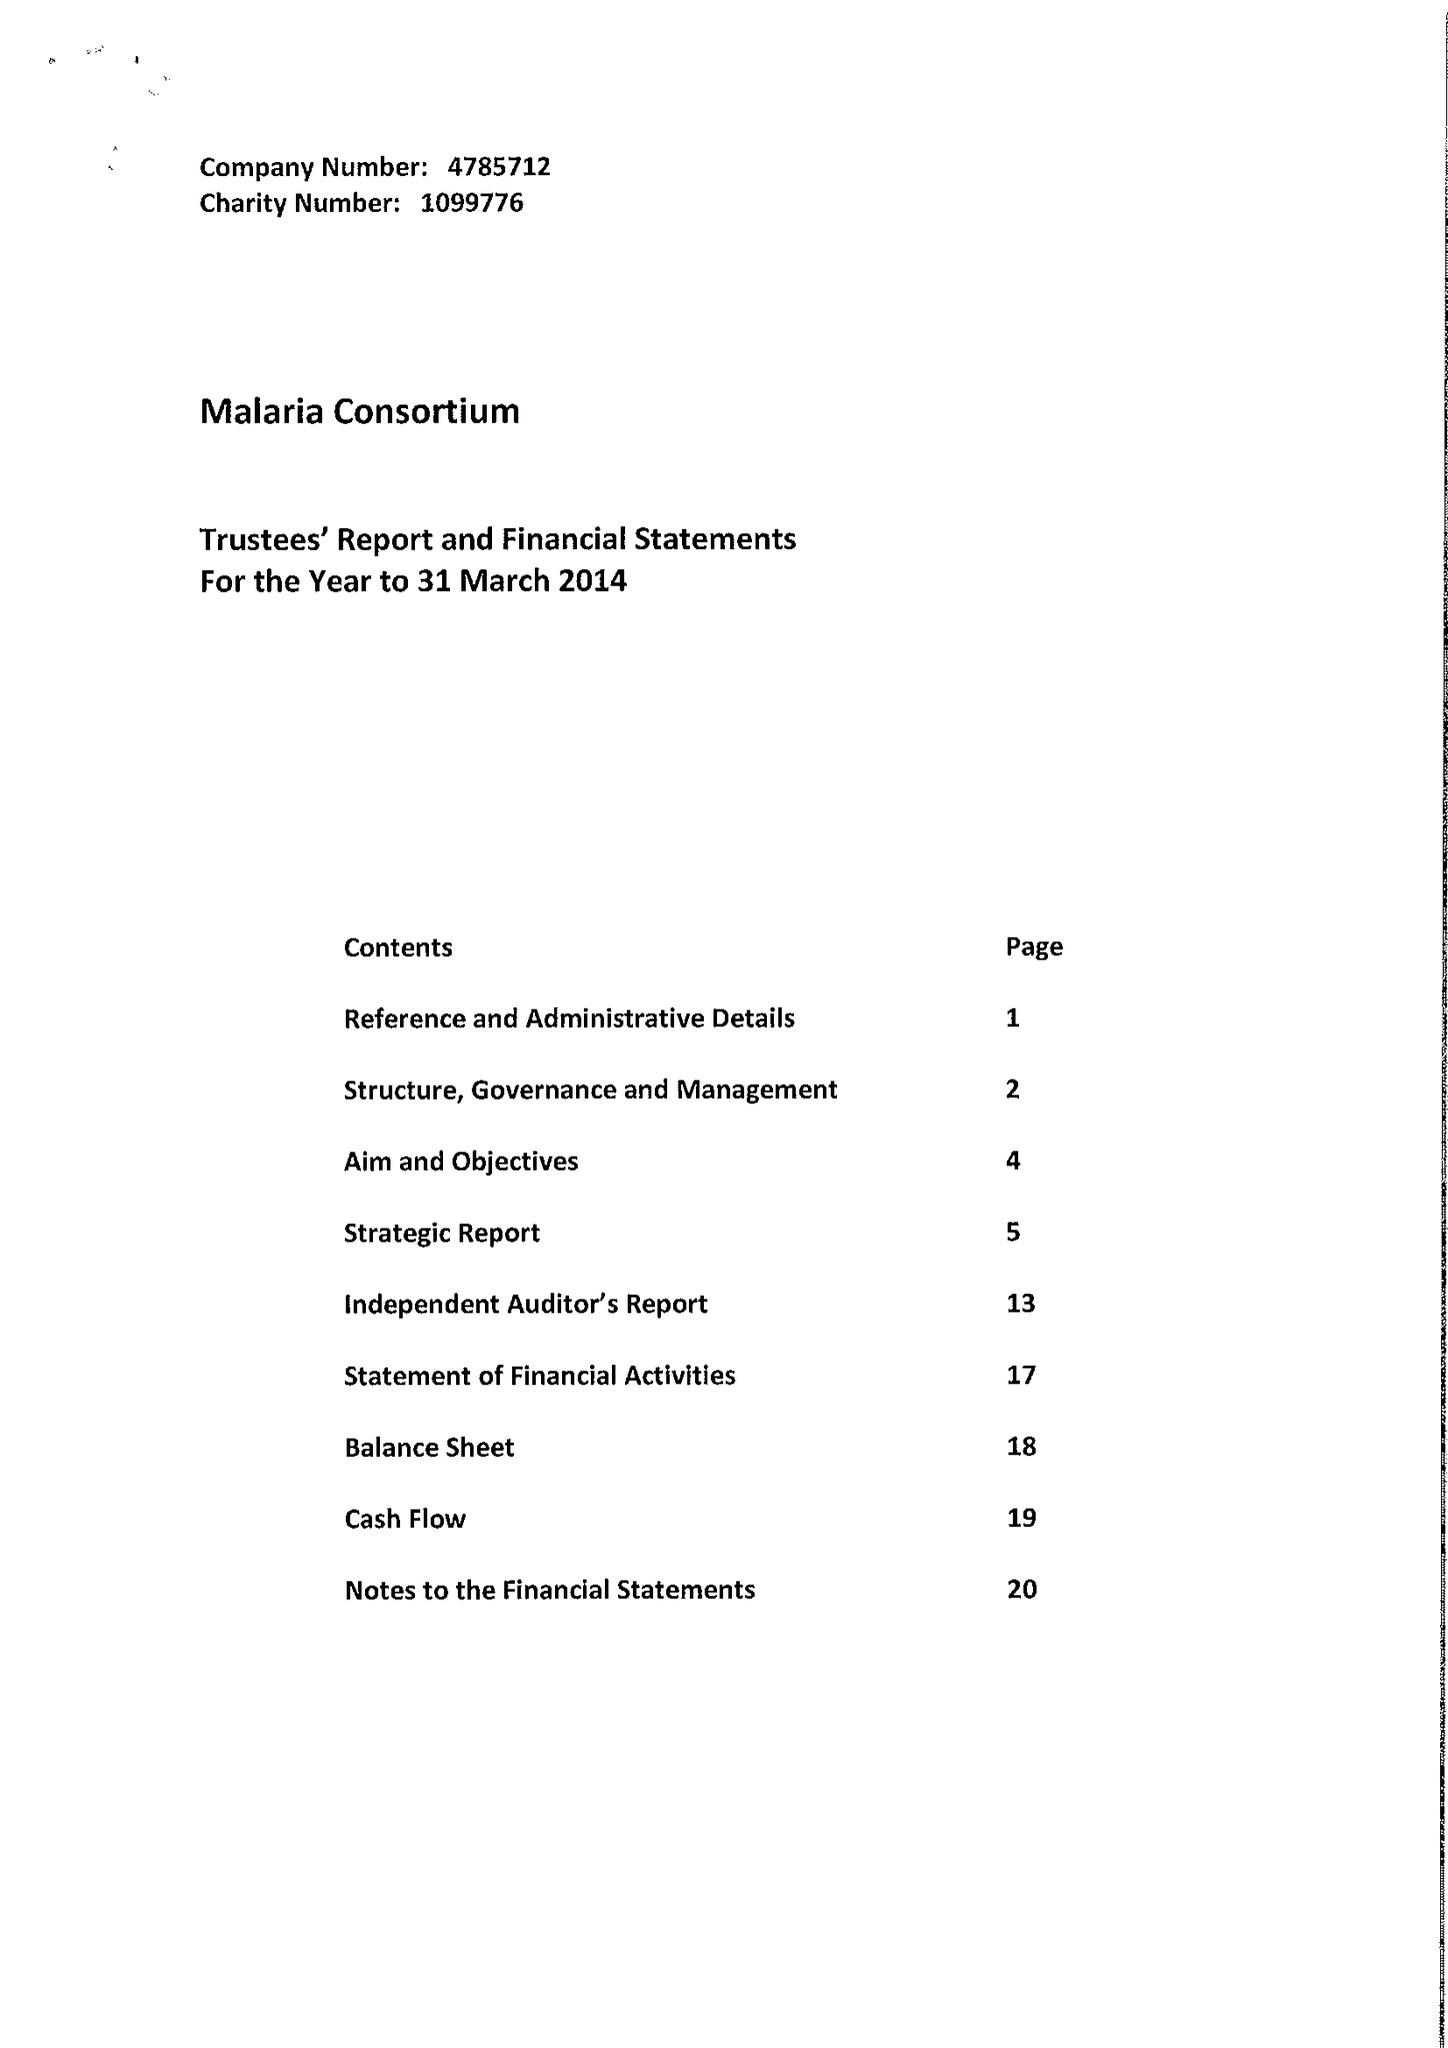What is the value for the address__street_line?
Answer the question using a single word or phrase. 244-254 CAMBRIDGE HEATH ROAD 